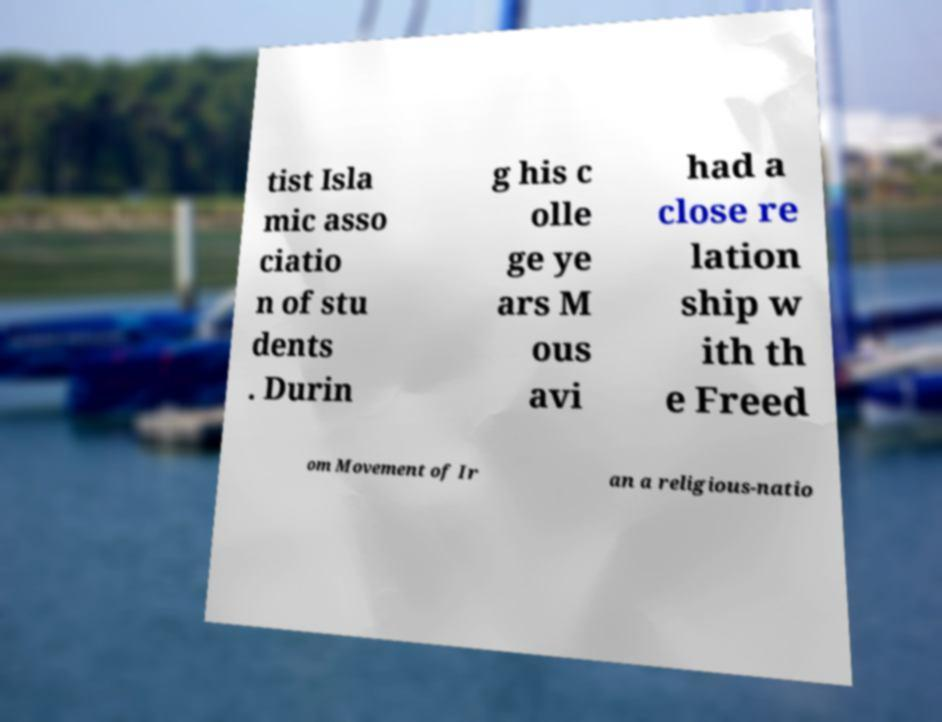Can you read and provide the text displayed in the image?This photo seems to have some interesting text. Can you extract and type it out for me? tist Isla mic asso ciatio n of stu dents . Durin g his c olle ge ye ars M ous avi had a close re lation ship w ith th e Freed om Movement of Ir an a religious-natio 